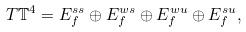<formula> <loc_0><loc_0><loc_500><loc_500>T \mathbb { T } ^ { 4 } = E _ { f } ^ { s s } \oplus E _ { f } ^ { w s } \oplus E _ { f } ^ { w u } \oplus E _ { f } ^ { s u } ,</formula> 